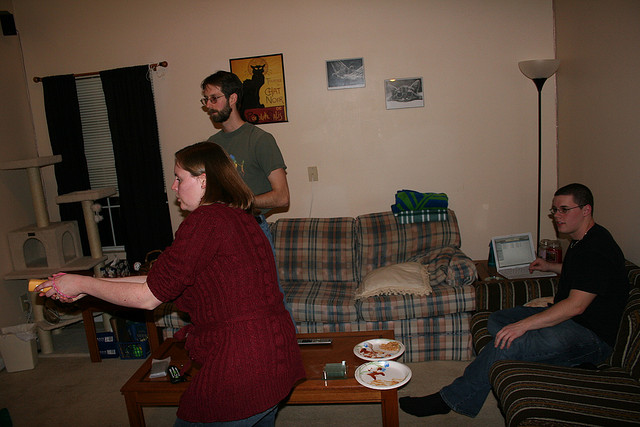<image>Is that a Wii controller? I'm not sure if that's a Wii controller. The answer can be both yes and no. Is it day or night? I am not certain if it's day or night. However, it is predominantly seen as night. Who has green socks on? It is ambiguous who has green socks on. Some say a man has them, while others say there is no one. What team Jersey is the boy wearing? The boy is not wearing a team jersey. What kind of food is the man holding? I am not sure what kind of food the man is holding. It could be pizza, french fry, cake, or none. What pattern is on her shirt? I don't know the exact pattern on her shirt; it could be stripes, cable knit, solid, or even a random pattern. What are the words on the green shirt? There are no visible words on the green shirt. Is that a Wii controller? I don't know if that is a Wii controller. It is possible that it is a Wii controller, but I am not sure. Is it day or night? It is unknown if it is day or night. However, it can be seen night. Who has green socks on? There is no one in the image who has green socks on. What team Jersey is the boy wearing? The boy is not wearing any team jersey. What kind of food is the man holding? I am not sure what kind of food the man is holding. It can be pizza, french fry, cake or none. What pattern is on her shirt? It is not clear what pattern is on her shirt. It can be seen as 'stripe', 'stripes', 'cable knit', 'designs', 'solid', 'none', 'random pattern', 'flowers', or 'stitched'. What are the words on the green shirt? I don't know what are the words on the green shirt. It is not visible in the image. 